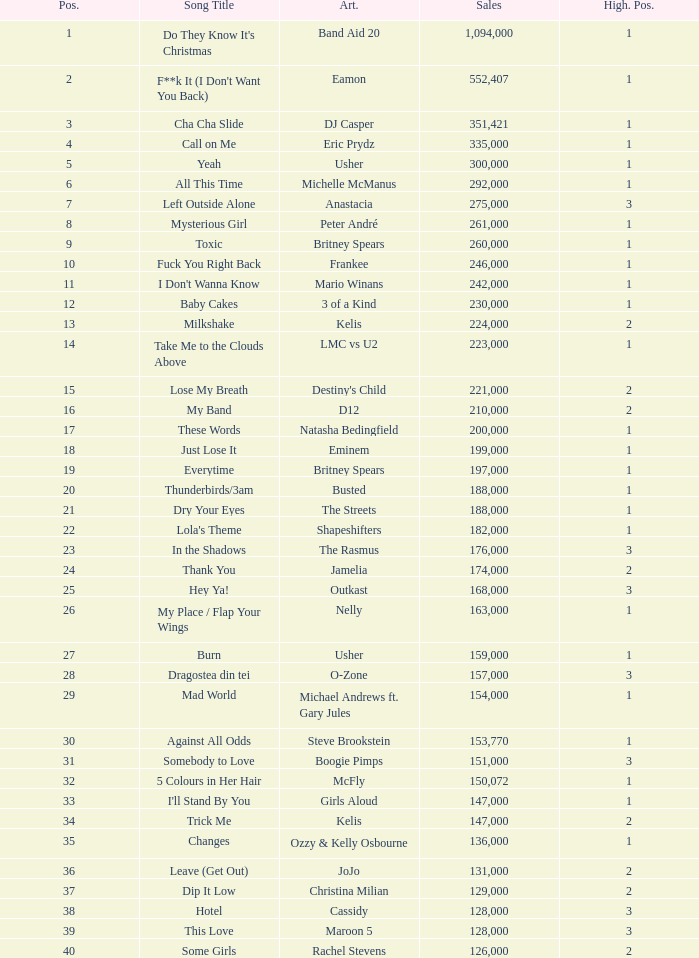What is the most sales by a song with a position higher than 3? None. 